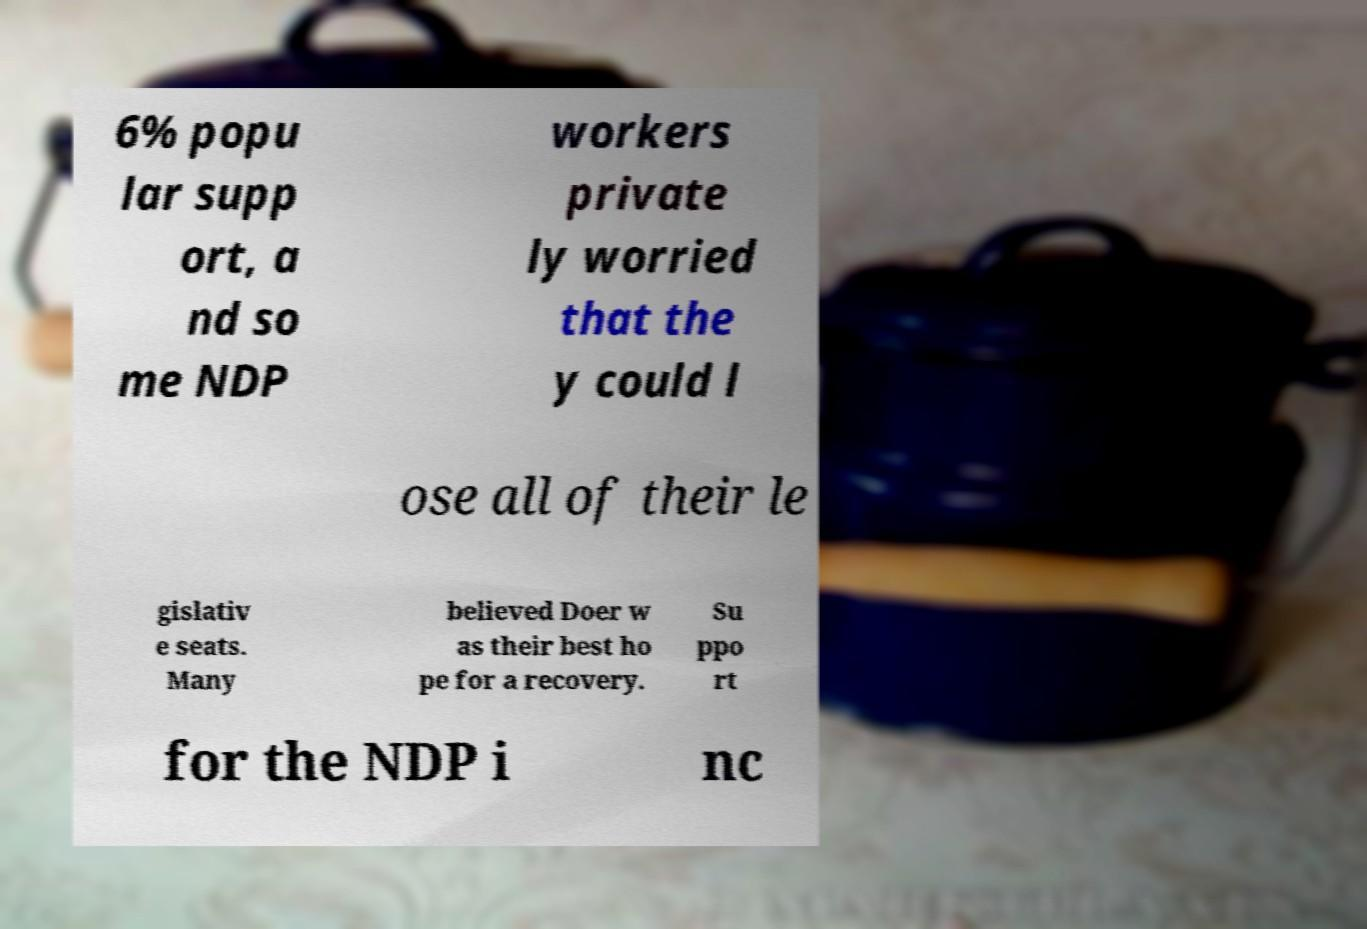I need the written content from this picture converted into text. Can you do that? 6% popu lar supp ort, a nd so me NDP workers private ly worried that the y could l ose all of their le gislativ e seats. Many believed Doer w as their best ho pe for a recovery. Su ppo rt for the NDP i nc 